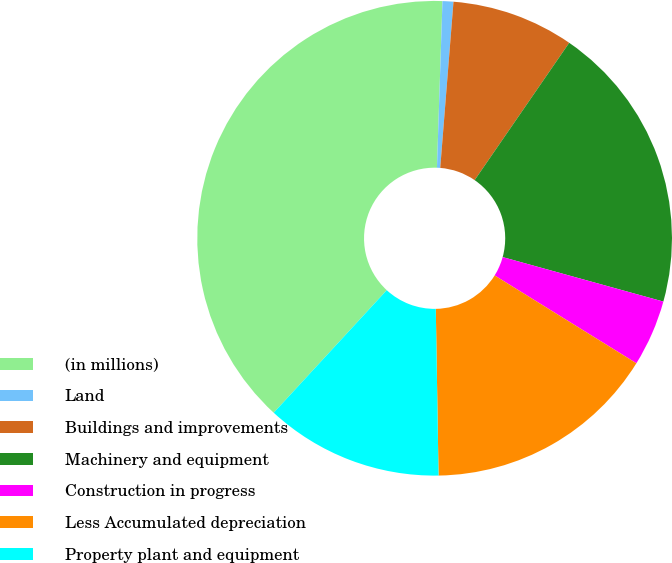<chart> <loc_0><loc_0><loc_500><loc_500><pie_chart><fcel>(in millions)<fcel>Land<fcel>Buildings and improvements<fcel>Machinery and equipment<fcel>Construction in progress<fcel>Less Accumulated depreciation<fcel>Property plant and equipment<nl><fcel>38.67%<fcel>0.74%<fcel>8.33%<fcel>19.7%<fcel>4.53%<fcel>15.91%<fcel>12.12%<nl></chart> 